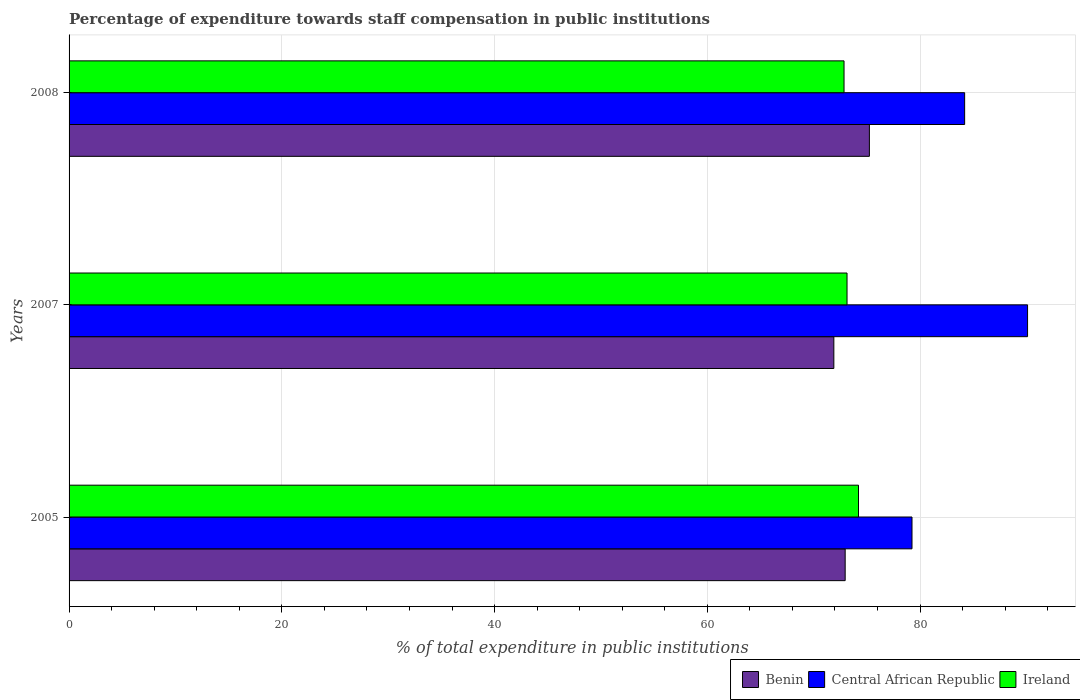How many different coloured bars are there?
Offer a very short reply. 3. Are the number of bars on each tick of the Y-axis equal?
Give a very brief answer. Yes. How many bars are there on the 3rd tick from the bottom?
Offer a very short reply. 3. What is the label of the 3rd group of bars from the top?
Your answer should be very brief. 2005. What is the percentage of expenditure towards staff compensation in Ireland in 2007?
Offer a terse response. 73.13. Across all years, what is the maximum percentage of expenditure towards staff compensation in Central African Republic?
Offer a very short reply. 90.11. Across all years, what is the minimum percentage of expenditure towards staff compensation in Central African Republic?
Make the answer very short. 79.24. What is the total percentage of expenditure towards staff compensation in Central African Republic in the graph?
Offer a very short reply. 253.54. What is the difference between the percentage of expenditure towards staff compensation in Benin in 2007 and that in 2008?
Provide a succinct answer. -3.34. What is the difference between the percentage of expenditure towards staff compensation in Benin in 2008 and the percentage of expenditure towards staff compensation in Central African Republic in 2007?
Your response must be concise. -14.87. What is the average percentage of expenditure towards staff compensation in Central African Republic per year?
Ensure brevity in your answer.  84.51. In the year 2007, what is the difference between the percentage of expenditure towards staff compensation in Central African Republic and percentage of expenditure towards staff compensation in Benin?
Make the answer very short. 18.21. In how many years, is the percentage of expenditure towards staff compensation in Ireland greater than 24 %?
Provide a succinct answer. 3. What is the ratio of the percentage of expenditure towards staff compensation in Benin in 2005 to that in 2008?
Give a very brief answer. 0.97. Is the percentage of expenditure towards staff compensation in Benin in 2005 less than that in 2008?
Give a very brief answer. Yes. Is the difference between the percentage of expenditure towards staff compensation in Central African Republic in 2005 and 2007 greater than the difference between the percentage of expenditure towards staff compensation in Benin in 2005 and 2007?
Your answer should be compact. No. What is the difference between the highest and the second highest percentage of expenditure towards staff compensation in Ireland?
Make the answer very short. 1.08. What is the difference between the highest and the lowest percentage of expenditure towards staff compensation in Benin?
Your answer should be very brief. 3.34. What does the 1st bar from the top in 2007 represents?
Ensure brevity in your answer.  Ireland. What does the 3rd bar from the bottom in 2007 represents?
Keep it short and to the point. Ireland. Is it the case that in every year, the sum of the percentage of expenditure towards staff compensation in Central African Republic and percentage of expenditure towards staff compensation in Benin is greater than the percentage of expenditure towards staff compensation in Ireland?
Ensure brevity in your answer.  Yes. Are all the bars in the graph horizontal?
Give a very brief answer. Yes. How many years are there in the graph?
Keep it short and to the point. 3. Are the values on the major ticks of X-axis written in scientific E-notation?
Offer a very short reply. No. Does the graph contain any zero values?
Provide a succinct answer. No. How many legend labels are there?
Your answer should be compact. 3. How are the legend labels stacked?
Your response must be concise. Horizontal. What is the title of the graph?
Offer a very short reply. Percentage of expenditure towards staff compensation in public institutions. Does "Isle of Man" appear as one of the legend labels in the graph?
Provide a succinct answer. No. What is the label or title of the X-axis?
Offer a very short reply. % of total expenditure in public institutions. What is the label or title of the Y-axis?
Make the answer very short. Years. What is the % of total expenditure in public institutions in Benin in 2005?
Your answer should be very brief. 72.96. What is the % of total expenditure in public institutions in Central African Republic in 2005?
Your answer should be compact. 79.24. What is the % of total expenditure in public institutions of Ireland in 2005?
Make the answer very short. 74.21. What is the % of total expenditure in public institutions of Benin in 2007?
Offer a terse response. 71.89. What is the % of total expenditure in public institutions of Central African Republic in 2007?
Your answer should be compact. 90.11. What is the % of total expenditure in public institutions in Ireland in 2007?
Offer a terse response. 73.13. What is the % of total expenditure in public institutions in Benin in 2008?
Your answer should be very brief. 75.24. What is the % of total expenditure in public institutions of Central African Republic in 2008?
Offer a terse response. 84.19. What is the % of total expenditure in public institutions of Ireland in 2008?
Make the answer very short. 72.85. Across all years, what is the maximum % of total expenditure in public institutions in Benin?
Keep it short and to the point. 75.24. Across all years, what is the maximum % of total expenditure in public institutions of Central African Republic?
Offer a very short reply. 90.11. Across all years, what is the maximum % of total expenditure in public institutions of Ireland?
Provide a short and direct response. 74.21. Across all years, what is the minimum % of total expenditure in public institutions in Benin?
Provide a succinct answer. 71.89. Across all years, what is the minimum % of total expenditure in public institutions in Central African Republic?
Offer a very short reply. 79.24. Across all years, what is the minimum % of total expenditure in public institutions of Ireland?
Ensure brevity in your answer.  72.85. What is the total % of total expenditure in public institutions of Benin in the graph?
Give a very brief answer. 220.09. What is the total % of total expenditure in public institutions of Central African Republic in the graph?
Provide a succinct answer. 253.54. What is the total % of total expenditure in public institutions in Ireland in the graph?
Offer a very short reply. 220.2. What is the difference between the % of total expenditure in public institutions in Benin in 2005 and that in 2007?
Ensure brevity in your answer.  1.07. What is the difference between the % of total expenditure in public institutions of Central African Republic in 2005 and that in 2007?
Ensure brevity in your answer.  -10.86. What is the difference between the % of total expenditure in public institutions of Ireland in 2005 and that in 2007?
Ensure brevity in your answer.  1.08. What is the difference between the % of total expenditure in public institutions of Benin in 2005 and that in 2008?
Your answer should be very brief. -2.28. What is the difference between the % of total expenditure in public institutions in Central African Republic in 2005 and that in 2008?
Provide a succinct answer. -4.95. What is the difference between the % of total expenditure in public institutions in Ireland in 2005 and that in 2008?
Give a very brief answer. 1.36. What is the difference between the % of total expenditure in public institutions in Benin in 2007 and that in 2008?
Keep it short and to the point. -3.34. What is the difference between the % of total expenditure in public institutions of Central African Republic in 2007 and that in 2008?
Provide a succinct answer. 5.92. What is the difference between the % of total expenditure in public institutions of Ireland in 2007 and that in 2008?
Make the answer very short. 0.28. What is the difference between the % of total expenditure in public institutions of Benin in 2005 and the % of total expenditure in public institutions of Central African Republic in 2007?
Offer a very short reply. -17.15. What is the difference between the % of total expenditure in public institutions in Benin in 2005 and the % of total expenditure in public institutions in Ireland in 2007?
Provide a succinct answer. -0.17. What is the difference between the % of total expenditure in public institutions in Central African Republic in 2005 and the % of total expenditure in public institutions in Ireland in 2007?
Keep it short and to the point. 6.11. What is the difference between the % of total expenditure in public institutions of Benin in 2005 and the % of total expenditure in public institutions of Central African Republic in 2008?
Provide a short and direct response. -11.23. What is the difference between the % of total expenditure in public institutions in Benin in 2005 and the % of total expenditure in public institutions in Ireland in 2008?
Provide a succinct answer. 0.11. What is the difference between the % of total expenditure in public institutions in Central African Republic in 2005 and the % of total expenditure in public institutions in Ireland in 2008?
Offer a very short reply. 6.39. What is the difference between the % of total expenditure in public institutions of Benin in 2007 and the % of total expenditure in public institutions of Central African Republic in 2008?
Your response must be concise. -12.3. What is the difference between the % of total expenditure in public institutions of Benin in 2007 and the % of total expenditure in public institutions of Ireland in 2008?
Offer a very short reply. -0.96. What is the difference between the % of total expenditure in public institutions in Central African Republic in 2007 and the % of total expenditure in public institutions in Ireland in 2008?
Your answer should be very brief. 17.25. What is the average % of total expenditure in public institutions in Benin per year?
Offer a very short reply. 73.36. What is the average % of total expenditure in public institutions in Central African Republic per year?
Ensure brevity in your answer.  84.51. What is the average % of total expenditure in public institutions of Ireland per year?
Provide a short and direct response. 73.4. In the year 2005, what is the difference between the % of total expenditure in public institutions of Benin and % of total expenditure in public institutions of Central African Republic?
Give a very brief answer. -6.28. In the year 2005, what is the difference between the % of total expenditure in public institutions in Benin and % of total expenditure in public institutions in Ireland?
Give a very brief answer. -1.25. In the year 2005, what is the difference between the % of total expenditure in public institutions in Central African Republic and % of total expenditure in public institutions in Ireland?
Your answer should be compact. 5.03. In the year 2007, what is the difference between the % of total expenditure in public institutions of Benin and % of total expenditure in public institutions of Central African Republic?
Your answer should be very brief. -18.21. In the year 2007, what is the difference between the % of total expenditure in public institutions in Benin and % of total expenditure in public institutions in Ireland?
Provide a succinct answer. -1.24. In the year 2007, what is the difference between the % of total expenditure in public institutions in Central African Republic and % of total expenditure in public institutions in Ireland?
Your answer should be compact. 16.97. In the year 2008, what is the difference between the % of total expenditure in public institutions in Benin and % of total expenditure in public institutions in Central African Republic?
Your answer should be compact. -8.95. In the year 2008, what is the difference between the % of total expenditure in public institutions of Benin and % of total expenditure in public institutions of Ireland?
Your answer should be compact. 2.38. In the year 2008, what is the difference between the % of total expenditure in public institutions in Central African Republic and % of total expenditure in public institutions in Ireland?
Provide a succinct answer. 11.34. What is the ratio of the % of total expenditure in public institutions of Benin in 2005 to that in 2007?
Offer a terse response. 1.01. What is the ratio of the % of total expenditure in public institutions of Central African Republic in 2005 to that in 2007?
Your answer should be very brief. 0.88. What is the ratio of the % of total expenditure in public institutions of Ireland in 2005 to that in 2007?
Your answer should be very brief. 1.01. What is the ratio of the % of total expenditure in public institutions in Benin in 2005 to that in 2008?
Keep it short and to the point. 0.97. What is the ratio of the % of total expenditure in public institutions of Ireland in 2005 to that in 2008?
Keep it short and to the point. 1.02. What is the ratio of the % of total expenditure in public institutions of Benin in 2007 to that in 2008?
Offer a terse response. 0.96. What is the ratio of the % of total expenditure in public institutions in Central African Republic in 2007 to that in 2008?
Your answer should be compact. 1.07. What is the ratio of the % of total expenditure in public institutions of Ireland in 2007 to that in 2008?
Make the answer very short. 1. What is the difference between the highest and the second highest % of total expenditure in public institutions in Benin?
Give a very brief answer. 2.28. What is the difference between the highest and the second highest % of total expenditure in public institutions in Central African Republic?
Your response must be concise. 5.92. What is the difference between the highest and the second highest % of total expenditure in public institutions in Ireland?
Offer a very short reply. 1.08. What is the difference between the highest and the lowest % of total expenditure in public institutions in Benin?
Your answer should be very brief. 3.34. What is the difference between the highest and the lowest % of total expenditure in public institutions of Central African Republic?
Make the answer very short. 10.86. What is the difference between the highest and the lowest % of total expenditure in public institutions in Ireland?
Give a very brief answer. 1.36. 